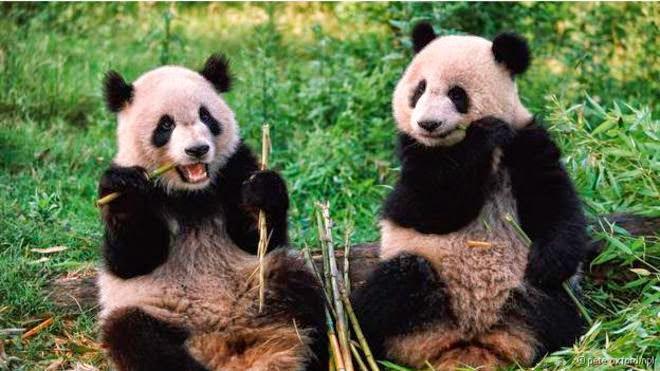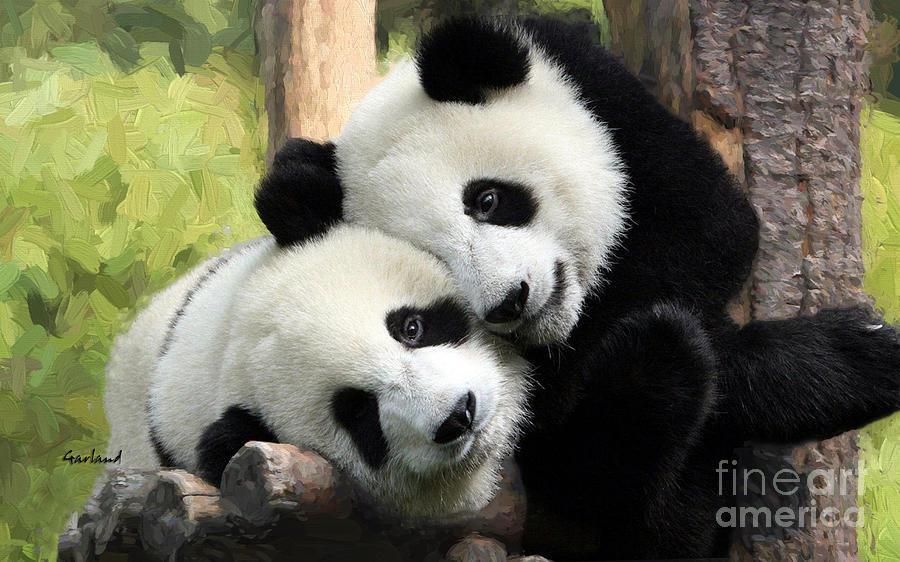The first image is the image on the left, the second image is the image on the right. Given the left and right images, does the statement "One panda is sitting on a branch in the right image." hold true? Answer yes or no. No. 